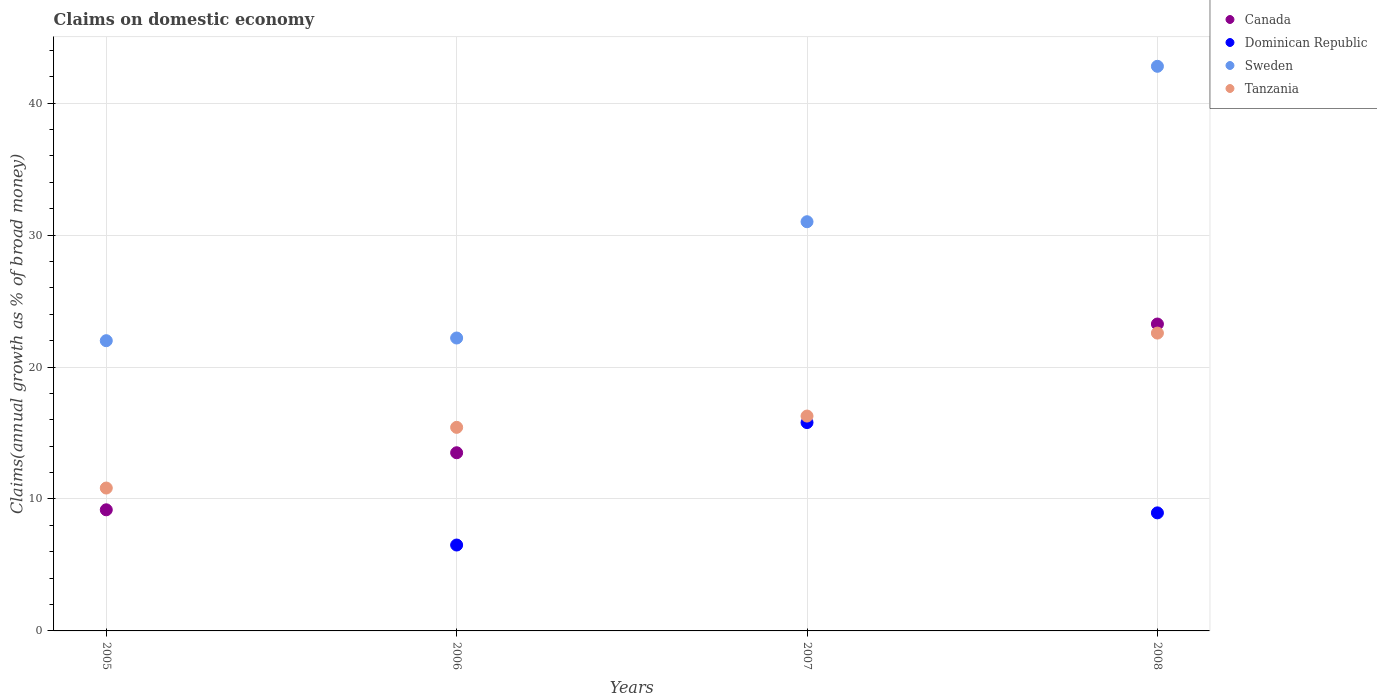How many different coloured dotlines are there?
Your response must be concise. 4. Is the number of dotlines equal to the number of legend labels?
Offer a terse response. No. What is the percentage of broad money claimed on domestic economy in Canada in 2008?
Your response must be concise. 23.26. Across all years, what is the maximum percentage of broad money claimed on domestic economy in Sweden?
Give a very brief answer. 42.8. Across all years, what is the minimum percentage of broad money claimed on domestic economy in Sweden?
Keep it short and to the point. 22. In which year was the percentage of broad money claimed on domestic economy in Canada maximum?
Offer a very short reply. 2008. What is the total percentage of broad money claimed on domestic economy in Dominican Republic in the graph?
Provide a short and direct response. 31.25. What is the difference between the percentage of broad money claimed on domestic economy in Sweden in 2007 and that in 2008?
Your answer should be compact. -11.78. What is the difference between the percentage of broad money claimed on domestic economy in Dominican Republic in 2006 and the percentage of broad money claimed on domestic economy in Canada in 2008?
Your response must be concise. -16.75. What is the average percentage of broad money claimed on domestic economy in Canada per year?
Offer a very short reply. 11.49. In the year 2007, what is the difference between the percentage of broad money claimed on domestic economy in Tanzania and percentage of broad money claimed on domestic economy in Sweden?
Keep it short and to the point. -14.73. What is the ratio of the percentage of broad money claimed on domestic economy in Dominican Republic in 2006 to that in 2007?
Give a very brief answer. 0.41. Is the difference between the percentage of broad money claimed on domestic economy in Tanzania in 2005 and 2007 greater than the difference between the percentage of broad money claimed on domestic economy in Sweden in 2005 and 2007?
Your answer should be compact. Yes. What is the difference between the highest and the second highest percentage of broad money claimed on domestic economy in Sweden?
Ensure brevity in your answer.  11.78. What is the difference between the highest and the lowest percentage of broad money claimed on domestic economy in Sweden?
Ensure brevity in your answer.  20.8. In how many years, is the percentage of broad money claimed on domestic economy in Tanzania greater than the average percentage of broad money claimed on domestic economy in Tanzania taken over all years?
Offer a terse response. 2. Is it the case that in every year, the sum of the percentage of broad money claimed on domestic economy in Sweden and percentage of broad money claimed on domestic economy in Dominican Republic  is greater than the sum of percentage of broad money claimed on domestic economy in Tanzania and percentage of broad money claimed on domestic economy in Canada?
Keep it short and to the point. No. Is the percentage of broad money claimed on domestic economy in Dominican Republic strictly greater than the percentage of broad money claimed on domestic economy in Tanzania over the years?
Provide a short and direct response. No. How many dotlines are there?
Make the answer very short. 4. What is the difference between two consecutive major ticks on the Y-axis?
Your answer should be compact. 10. Are the values on the major ticks of Y-axis written in scientific E-notation?
Provide a short and direct response. No. Does the graph contain any zero values?
Give a very brief answer. Yes. Does the graph contain grids?
Offer a very short reply. Yes. How many legend labels are there?
Your answer should be very brief. 4. What is the title of the graph?
Your response must be concise. Claims on domestic economy. Does "Euro area" appear as one of the legend labels in the graph?
Keep it short and to the point. No. What is the label or title of the X-axis?
Make the answer very short. Years. What is the label or title of the Y-axis?
Make the answer very short. Claims(annual growth as % of broad money). What is the Claims(annual growth as % of broad money) in Canada in 2005?
Give a very brief answer. 9.18. What is the Claims(annual growth as % of broad money) in Dominican Republic in 2005?
Your answer should be compact. 0. What is the Claims(annual growth as % of broad money) of Sweden in 2005?
Your response must be concise. 22. What is the Claims(annual growth as % of broad money) of Tanzania in 2005?
Your response must be concise. 10.83. What is the Claims(annual growth as % of broad money) in Canada in 2006?
Keep it short and to the point. 13.5. What is the Claims(annual growth as % of broad money) in Dominican Republic in 2006?
Give a very brief answer. 6.51. What is the Claims(annual growth as % of broad money) in Sweden in 2006?
Offer a very short reply. 22.2. What is the Claims(annual growth as % of broad money) in Tanzania in 2006?
Keep it short and to the point. 15.43. What is the Claims(annual growth as % of broad money) of Canada in 2007?
Your answer should be very brief. 0. What is the Claims(annual growth as % of broad money) in Dominican Republic in 2007?
Provide a succinct answer. 15.79. What is the Claims(annual growth as % of broad money) of Sweden in 2007?
Your response must be concise. 31.01. What is the Claims(annual growth as % of broad money) in Tanzania in 2007?
Provide a short and direct response. 16.29. What is the Claims(annual growth as % of broad money) in Canada in 2008?
Provide a succinct answer. 23.26. What is the Claims(annual growth as % of broad money) in Dominican Republic in 2008?
Keep it short and to the point. 8.95. What is the Claims(annual growth as % of broad money) in Sweden in 2008?
Provide a short and direct response. 42.8. What is the Claims(annual growth as % of broad money) in Tanzania in 2008?
Keep it short and to the point. 22.57. Across all years, what is the maximum Claims(annual growth as % of broad money) in Canada?
Your response must be concise. 23.26. Across all years, what is the maximum Claims(annual growth as % of broad money) of Dominican Republic?
Provide a short and direct response. 15.79. Across all years, what is the maximum Claims(annual growth as % of broad money) in Sweden?
Offer a terse response. 42.8. Across all years, what is the maximum Claims(annual growth as % of broad money) of Tanzania?
Provide a short and direct response. 22.57. Across all years, what is the minimum Claims(annual growth as % of broad money) in Canada?
Give a very brief answer. 0. Across all years, what is the minimum Claims(annual growth as % of broad money) of Dominican Republic?
Make the answer very short. 0. Across all years, what is the minimum Claims(annual growth as % of broad money) in Sweden?
Your answer should be compact. 22. Across all years, what is the minimum Claims(annual growth as % of broad money) of Tanzania?
Your answer should be very brief. 10.83. What is the total Claims(annual growth as % of broad money) of Canada in the graph?
Offer a terse response. 45.95. What is the total Claims(annual growth as % of broad money) in Dominican Republic in the graph?
Make the answer very short. 31.25. What is the total Claims(annual growth as % of broad money) in Sweden in the graph?
Offer a terse response. 118.01. What is the total Claims(annual growth as % of broad money) in Tanzania in the graph?
Your answer should be compact. 65.12. What is the difference between the Claims(annual growth as % of broad money) of Canada in 2005 and that in 2006?
Your answer should be compact. -4.32. What is the difference between the Claims(annual growth as % of broad money) in Sweden in 2005 and that in 2006?
Offer a very short reply. -0.2. What is the difference between the Claims(annual growth as % of broad money) of Tanzania in 2005 and that in 2006?
Provide a succinct answer. -4.6. What is the difference between the Claims(annual growth as % of broad money) of Sweden in 2005 and that in 2007?
Give a very brief answer. -9.02. What is the difference between the Claims(annual growth as % of broad money) in Tanzania in 2005 and that in 2007?
Your answer should be very brief. -5.46. What is the difference between the Claims(annual growth as % of broad money) of Canada in 2005 and that in 2008?
Keep it short and to the point. -14.08. What is the difference between the Claims(annual growth as % of broad money) of Sweden in 2005 and that in 2008?
Provide a succinct answer. -20.8. What is the difference between the Claims(annual growth as % of broad money) in Tanzania in 2005 and that in 2008?
Give a very brief answer. -11.74. What is the difference between the Claims(annual growth as % of broad money) in Dominican Republic in 2006 and that in 2007?
Offer a very short reply. -9.28. What is the difference between the Claims(annual growth as % of broad money) of Sweden in 2006 and that in 2007?
Offer a very short reply. -8.81. What is the difference between the Claims(annual growth as % of broad money) of Tanzania in 2006 and that in 2007?
Offer a very short reply. -0.86. What is the difference between the Claims(annual growth as % of broad money) in Canada in 2006 and that in 2008?
Your response must be concise. -9.76. What is the difference between the Claims(annual growth as % of broad money) in Dominican Republic in 2006 and that in 2008?
Your answer should be compact. -2.44. What is the difference between the Claims(annual growth as % of broad money) in Sweden in 2006 and that in 2008?
Your answer should be very brief. -20.59. What is the difference between the Claims(annual growth as % of broad money) in Tanzania in 2006 and that in 2008?
Your answer should be very brief. -7.15. What is the difference between the Claims(annual growth as % of broad money) of Dominican Republic in 2007 and that in 2008?
Provide a succinct answer. 6.84. What is the difference between the Claims(annual growth as % of broad money) of Sweden in 2007 and that in 2008?
Offer a very short reply. -11.78. What is the difference between the Claims(annual growth as % of broad money) of Tanzania in 2007 and that in 2008?
Provide a succinct answer. -6.29. What is the difference between the Claims(annual growth as % of broad money) of Canada in 2005 and the Claims(annual growth as % of broad money) of Dominican Republic in 2006?
Your answer should be very brief. 2.67. What is the difference between the Claims(annual growth as % of broad money) in Canada in 2005 and the Claims(annual growth as % of broad money) in Sweden in 2006?
Keep it short and to the point. -13.02. What is the difference between the Claims(annual growth as % of broad money) in Canada in 2005 and the Claims(annual growth as % of broad money) in Tanzania in 2006?
Give a very brief answer. -6.25. What is the difference between the Claims(annual growth as % of broad money) in Sweden in 2005 and the Claims(annual growth as % of broad money) in Tanzania in 2006?
Keep it short and to the point. 6.57. What is the difference between the Claims(annual growth as % of broad money) of Canada in 2005 and the Claims(annual growth as % of broad money) of Dominican Republic in 2007?
Keep it short and to the point. -6.61. What is the difference between the Claims(annual growth as % of broad money) of Canada in 2005 and the Claims(annual growth as % of broad money) of Sweden in 2007?
Provide a succinct answer. -21.83. What is the difference between the Claims(annual growth as % of broad money) in Canada in 2005 and the Claims(annual growth as % of broad money) in Tanzania in 2007?
Your response must be concise. -7.11. What is the difference between the Claims(annual growth as % of broad money) in Sweden in 2005 and the Claims(annual growth as % of broad money) in Tanzania in 2007?
Give a very brief answer. 5.71. What is the difference between the Claims(annual growth as % of broad money) of Canada in 2005 and the Claims(annual growth as % of broad money) of Dominican Republic in 2008?
Keep it short and to the point. 0.23. What is the difference between the Claims(annual growth as % of broad money) in Canada in 2005 and the Claims(annual growth as % of broad money) in Sweden in 2008?
Give a very brief answer. -33.62. What is the difference between the Claims(annual growth as % of broad money) of Canada in 2005 and the Claims(annual growth as % of broad money) of Tanzania in 2008?
Provide a short and direct response. -13.39. What is the difference between the Claims(annual growth as % of broad money) of Sweden in 2005 and the Claims(annual growth as % of broad money) of Tanzania in 2008?
Provide a succinct answer. -0.58. What is the difference between the Claims(annual growth as % of broad money) of Canada in 2006 and the Claims(annual growth as % of broad money) of Dominican Republic in 2007?
Your response must be concise. -2.29. What is the difference between the Claims(annual growth as % of broad money) of Canada in 2006 and the Claims(annual growth as % of broad money) of Sweden in 2007?
Provide a succinct answer. -17.51. What is the difference between the Claims(annual growth as % of broad money) of Canada in 2006 and the Claims(annual growth as % of broad money) of Tanzania in 2007?
Offer a terse response. -2.78. What is the difference between the Claims(annual growth as % of broad money) of Dominican Republic in 2006 and the Claims(annual growth as % of broad money) of Sweden in 2007?
Make the answer very short. -24.5. What is the difference between the Claims(annual growth as % of broad money) of Dominican Republic in 2006 and the Claims(annual growth as % of broad money) of Tanzania in 2007?
Give a very brief answer. -9.78. What is the difference between the Claims(annual growth as % of broad money) in Sweden in 2006 and the Claims(annual growth as % of broad money) in Tanzania in 2007?
Make the answer very short. 5.92. What is the difference between the Claims(annual growth as % of broad money) in Canada in 2006 and the Claims(annual growth as % of broad money) in Dominican Republic in 2008?
Provide a succinct answer. 4.56. What is the difference between the Claims(annual growth as % of broad money) in Canada in 2006 and the Claims(annual growth as % of broad money) in Sweden in 2008?
Your response must be concise. -29.29. What is the difference between the Claims(annual growth as % of broad money) of Canada in 2006 and the Claims(annual growth as % of broad money) of Tanzania in 2008?
Offer a terse response. -9.07. What is the difference between the Claims(annual growth as % of broad money) in Dominican Republic in 2006 and the Claims(annual growth as % of broad money) in Sweden in 2008?
Make the answer very short. -36.29. What is the difference between the Claims(annual growth as % of broad money) of Dominican Republic in 2006 and the Claims(annual growth as % of broad money) of Tanzania in 2008?
Your answer should be very brief. -16.06. What is the difference between the Claims(annual growth as % of broad money) in Sweden in 2006 and the Claims(annual growth as % of broad money) in Tanzania in 2008?
Make the answer very short. -0.37. What is the difference between the Claims(annual growth as % of broad money) of Dominican Republic in 2007 and the Claims(annual growth as % of broad money) of Sweden in 2008?
Provide a succinct answer. -27. What is the difference between the Claims(annual growth as % of broad money) of Dominican Republic in 2007 and the Claims(annual growth as % of broad money) of Tanzania in 2008?
Your answer should be very brief. -6.78. What is the difference between the Claims(annual growth as % of broad money) of Sweden in 2007 and the Claims(annual growth as % of broad money) of Tanzania in 2008?
Make the answer very short. 8.44. What is the average Claims(annual growth as % of broad money) in Canada per year?
Ensure brevity in your answer.  11.49. What is the average Claims(annual growth as % of broad money) in Dominican Republic per year?
Your answer should be compact. 7.81. What is the average Claims(annual growth as % of broad money) of Sweden per year?
Offer a terse response. 29.5. What is the average Claims(annual growth as % of broad money) in Tanzania per year?
Ensure brevity in your answer.  16.28. In the year 2005, what is the difference between the Claims(annual growth as % of broad money) in Canada and Claims(annual growth as % of broad money) in Sweden?
Give a very brief answer. -12.82. In the year 2005, what is the difference between the Claims(annual growth as % of broad money) of Canada and Claims(annual growth as % of broad money) of Tanzania?
Your answer should be very brief. -1.65. In the year 2005, what is the difference between the Claims(annual growth as % of broad money) of Sweden and Claims(annual growth as % of broad money) of Tanzania?
Provide a short and direct response. 11.17. In the year 2006, what is the difference between the Claims(annual growth as % of broad money) in Canada and Claims(annual growth as % of broad money) in Dominican Republic?
Make the answer very short. 6.99. In the year 2006, what is the difference between the Claims(annual growth as % of broad money) in Canada and Claims(annual growth as % of broad money) in Sweden?
Offer a very short reply. -8.7. In the year 2006, what is the difference between the Claims(annual growth as % of broad money) in Canada and Claims(annual growth as % of broad money) in Tanzania?
Your answer should be compact. -1.92. In the year 2006, what is the difference between the Claims(annual growth as % of broad money) of Dominican Republic and Claims(annual growth as % of broad money) of Sweden?
Your answer should be compact. -15.69. In the year 2006, what is the difference between the Claims(annual growth as % of broad money) of Dominican Republic and Claims(annual growth as % of broad money) of Tanzania?
Your answer should be very brief. -8.92. In the year 2006, what is the difference between the Claims(annual growth as % of broad money) in Sweden and Claims(annual growth as % of broad money) in Tanzania?
Provide a short and direct response. 6.77. In the year 2007, what is the difference between the Claims(annual growth as % of broad money) in Dominican Republic and Claims(annual growth as % of broad money) in Sweden?
Your answer should be very brief. -15.22. In the year 2007, what is the difference between the Claims(annual growth as % of broad money) in Dominican Republic and Claims(annual growth as % of broad money) in Tanzania?
Offer a very short reply. -0.49. In the year 2007, what is the difference between the Claims(annual growth as % of broad money) in Sweden and Claims(annual growth as % of broad money) in Tanzania?
Your answer should be compact. 14.73. In the year 2008, what is the difference between the Claims(annual growth as % of broad money) of Canada and Claims(annual growth as % of broad money) of Dominican Republic?
Your response must be concise. 14.31. In the year 2008, what is the difference between the Claims(annual growth as % of broad money) of Canada and Claims(annual growth as % of broad money) of Sweden?
Your answer should be very brief. -19.53. In the year 2008, what is the difference between the Claims(annual growth as % of broad money) of Canada and Claims(annual growth as % of broad money) of Tanzania?
Keep it short and to the point. 0.69. In the year 2008, what is the difference between the Claims(annual growth as % of broad money) of Dominican Republic and Claims(annual growth as % of broad money) of Sweden?
Your answer should be compact. -33.85. In the year 2008, what is the difference between the Claims(annual growth as % of broad money) in Dominican Republic and Claims(annual growth as % of broad money) in Tanzania?
Provide a succinct answer. -13.63. In the year 2008, what is the difference between the Claims(annual growth as % of broad money) of Sweden and Claims(annual growth as % of broad money) of Tanzania?
Ensure brevity in your answer.  20.22. What is the ratio of the Claims(annual growth as % of broad money) in Canada in 2005 to that in 2006?
Offer a terse response. 0.68. What is the ratio of the Claims(annual growth as % of broad money) in Sweden in 2005 to that in 2006?
Provide a short and direct response. 0.99. What is the ratio of the Claims(annual growth as % of broad money) in Tanzania in 2005 to that in 2006?
Offer a very short reply. 0.7. What is the ratio of the Claims(annual growth as % of broad money) in Sweden in 2005 to that in 2007?
Your answer should be very brief. 0.71. What is the ratio of the Claims(annual growth as % of broad money) of Tanzania in 2005 to that in 2007?
Provide a short and direct response. 0.67. What is the ratio of the Claims(annual growth as % of broad money) in Canada in 2005 to that in 2008?
Make the answer very short. 0.39. What is the ratio of the Claims(annual growth as % of broad money) of Sweden in 2005 to that in 2008?
Your answer should be very brief. 0.51. What is the ratio of the Claims(annual growth as % of broad money) of Tanzania in 2005 to that in 2008?
Your answer should be very brief. 0.48. What is the ratio of the Claims(annual growth as % of broad money) of Dominican Republic in 2006 to that in 2007?
Offer a very short reply. 0.41. What is the ratio of the Claims(annual growth as % of broad money) of Sweden in 2006 to that in 2007?
Offer a terse response. 0.72. What is the ratio of the Claims(annual growth as % of broad money) in Tanzania in 2006 to that in 2007?
Make the answer very short. 0.95. What is the ratio of the Claims(annual growth as % of broad money) in Canada in 2006 to that in 2008?
Make the answer very short. 0.58. What is the ratio of the Claims(annual growth as % of broad money) in Dominican Republic in 2006 to that in 2008?
Ensure brevity in your answer.  0.73. What is the ratio of the Claims(annual growth as % of broad money) in Sweden in 2006 to that in 2008?
Give a very brief answer. 0.52. What is the ratio of the Claims(annual growth as % of broad money) of Tanzania in 2006 to that in 2008?
Offer a terse response. 0.68. What is the ratio of the Claims(annual growth as % of broad money) in Dominican Republic in 2007 to that in 2008?
Offer a very short reply. 1.76. What is the ratio of the Claims(annual growth as % of broad money) in Sweden in 2007 to that in 2008?
Your response must be concise. 0.72. What is the ratio of the Claims(annual growth as % of broad money) in Tanzania in 2007 to that in 2008?
Keep it short and to the point. 0.72. What is the difference between the highest and the second highest Claims(annual growth as % of broad money) of Canada?
Offer a very short reply. 9.76. What is the difference between the highest and the second highest Claims(annual growth as % of broad money) of Dominican Republic?
Keep it short and to the point. 6.84. What is the difference between the highest and the second highest Claims(annual growth as % of broad money) of Sweden?
Keep it short and to the point. 11.78. What is the difference between the highest and the second highest Claims(annual growth as % of broad money) in Tanzania?
Your answer should be very brief. 6.29. What is the difference between the highest and the lowest Claims(annual growth as % of broad money) of Canada?
Your answer should be compact. 23.26. What is the difference between the highest and the lowest Claims(annual growth as % of broad money) of Dominican Republic?
Offer a very short reply. 15.79. What is the difference between the highest and the lowest Claims(annual growth as % of broad money) of Sweden?
Make the answer very short. 20.8. What is the difference between the highest and the lowest Claims(annual growth as % of broad money) in Tanzania?
Ensure brevity in your answer.  11.74. 